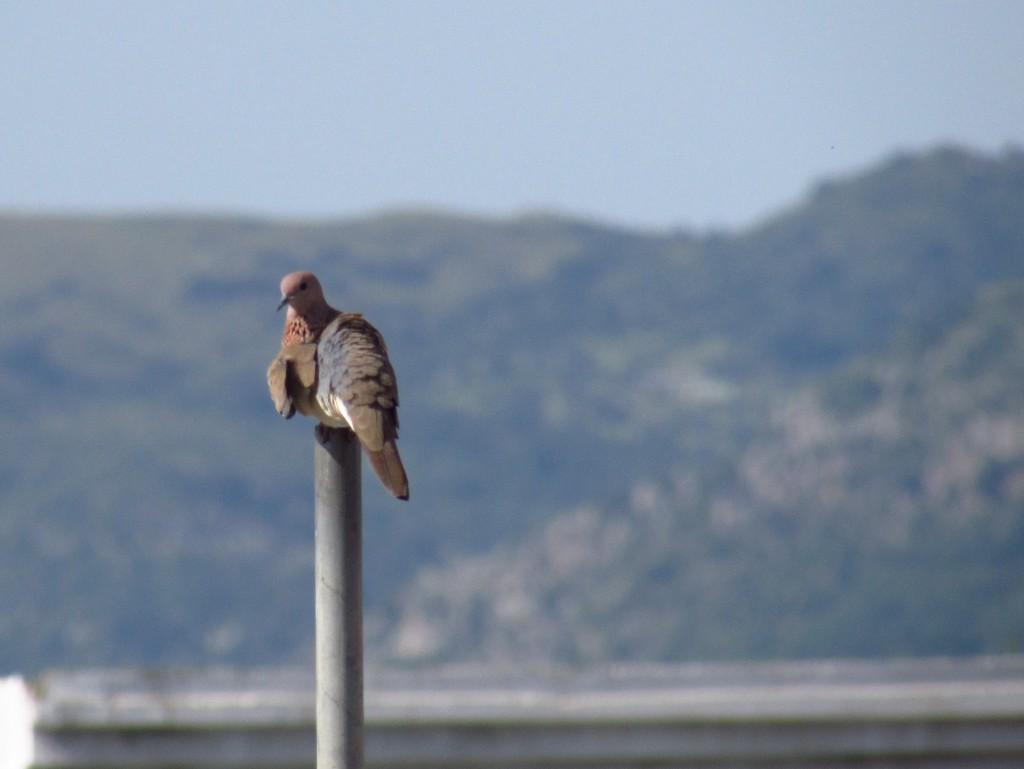What is the main subject of the image? The main subject of the image is a bird on a pole. What can be seen in the background of the image? There is greenery in the background of the image. What is visible at the top of the image? The sky is visible at the top of the image. What type of structure is at the bottom of the image? There appears to be a wall at the bottom of the image. What is the aftermath of the bird's self-reflection in the image? There is no indication of the bird's self-reflection or any aftermath in the image. 